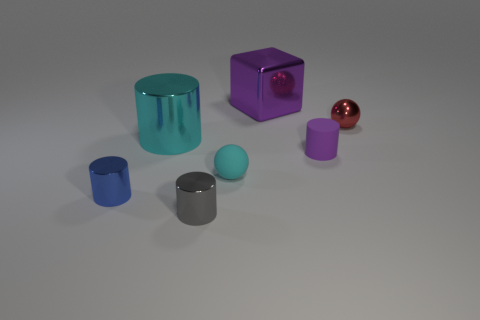Are any spheres visible?
Keep it short and to the point. Yes. Does the rubber sphere have the same color as the big thing left of the cyan rubber ball?
Offer a terse response. Yes. There is a thing that is the same color as the large metal block; what is its material?
Make the answer very short. Rubber. Are there any other things that have the same shape as the big purple metallic thing?
Your answer should be very brief. No. The tiny thing left of the cylinder in front of the small thing to the left of the small gray cylinder is what shape?
Provide a succinct answer. Cylinder. What shape is the small red object?
Ensure brevity in your answer.  Sphere. What color is the big shiny object that is in front of the big metallic block?
Your response must be concise. Cyan. Is the size of the metallic cylinder that is in front of the blue object the same as the tiny red metallic sphere?
Keep it short and to the point. Yes. There is a gray object that is the same shape as the big cyan metal object; what is its size?
Your response must be concise. Small. Do the tiny blue metallic object and the tiny purple rubber thing have the same shape?
Make the answer very short. Yes. 